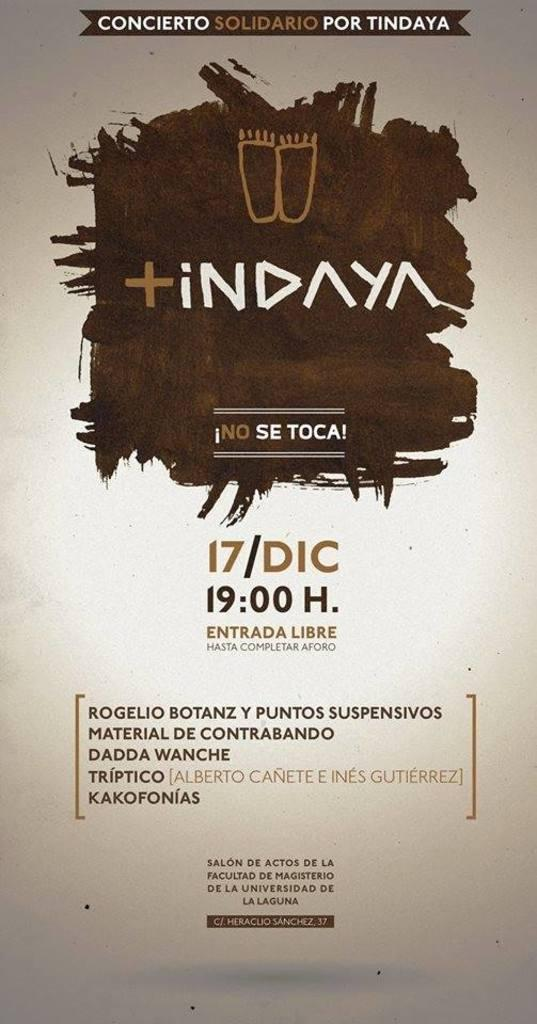What is present in the image that contains information or a message? There is a poster in the image. What can be found on the poster in the image? There is text on the poster. What type of wave can be seen crashing on the edge of the poster in the image? There is no wave or edge present on the poster in the image; it only contains text. 